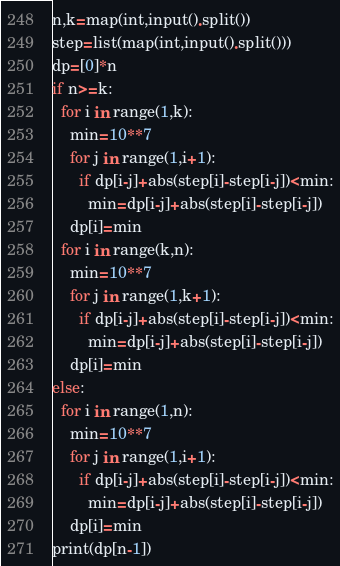Convert code to text. <code><loc_0><loc_0><loc_500><loc_500><_Python_>n,k=map(int,input().split())
step=list(map(int,input().split()))
dp=[0]*n
if n>=k:
  for i in range(1,k):
    min=10**7
    for j in range(1,i+1):
      if dp[i-j]+abs(step[i]-step[i-j])<min:
        min=dp[i-j]+abs(step[i]-step[i-j])
    dp[i]=min
  for i in range(k,n):
    min=10**7
    for j in range(1,k+1):
      if dp[i-j]+abs(step[i]-step[i-j])<min:
        min=dp[i-j]+abs(step[i]-step[i-j])
    dp[i]=min
else:
  for i in range(1,n):
    min=10**7
    for j in range(1,i+1):
      if dp[i-j]+abs(step[i]-step[i-j])<min:
        min=dp[i-j]+abs(step[i]-step[i-j])
    dp[i]=min
print(dp[n-1])</code> 